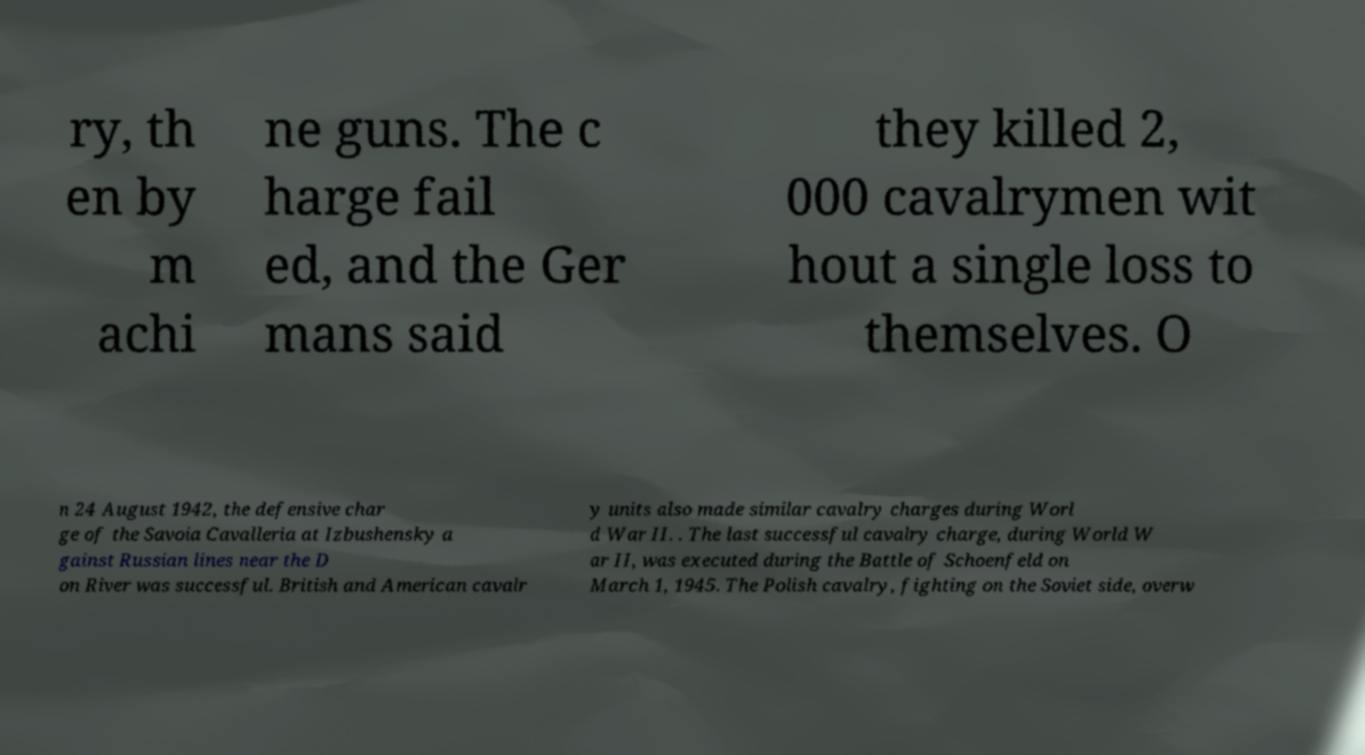Can you accurately transcribe the text from the provided image for me? ry, th en by m achi ne guns. The c harge fail ed, and the Ger mans said they killed 2, 000 cavalrymen wit hout a single loss to themselves. O n 24 August 1942, the defensive char ge of the Savoia Cavalleria at Izbushensky a gainst Russian lines near the D on River was successful. British and American cavalr y units also made similar cavalry charges during Worl d War II. . The last successful cavalry charge, during World W ar II, was executed during the Battle of Schoenfeld on March 1, 1945. The Polish cavalry, fighting on the Soviet side, overw 